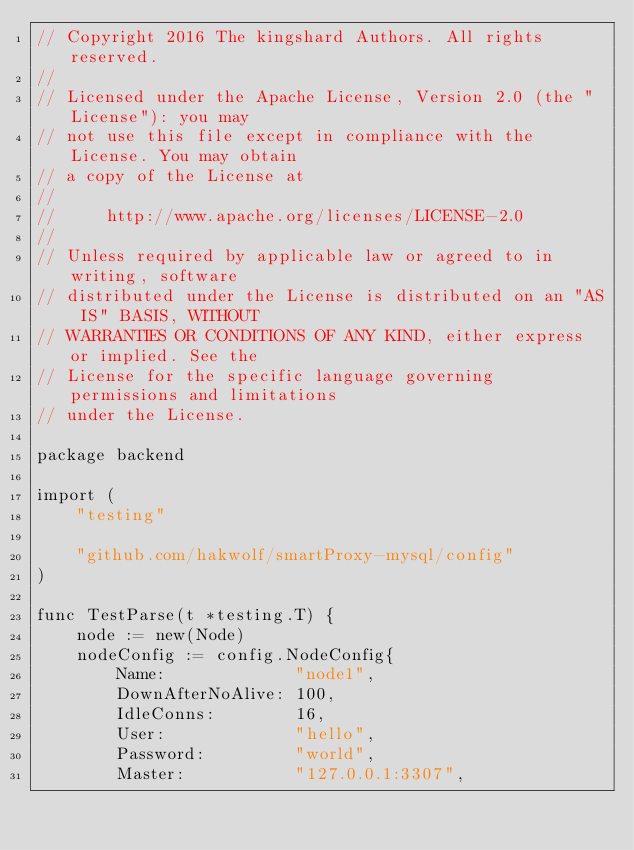<code> <loc_0><loc_0><loc_500><loc_500><_Go_>// Copyright 2016 The kingshard Authors. All rights reserved.
//
// Licensed under the Apache License, Version 2.0 (the "License"): you may
// not use this file except in compliance with the License. You may obtain
// a copy of the License at
//
//     http://www.apache.org/licenses/LICENSE-2.0
//
// Unless required by applicable law or agreed to in writing, software
// distributed under the License is distributed on an "AS IS" BASIS, WITHOUT
// WARRANTIES OR CONDITIONS OF ANY KIND, either express or implied. See the
// License for the specific language governing permissions and limitations
// under the License.

package backend

import (
	"testing"

	"github.com/hakwolf/smartProxy-mysql/config"
)

func TestParse(t *testing.T) {
	node := new(Node)
	nodeConfig := config.NodeConfig{
		Name:             "node1",
		DownAfterNoAlive: 100,
		IdleConns:        16,
		User:             "hello",
		Password:         "world",
		Master:           "127.0.0.1:3307",</code> 